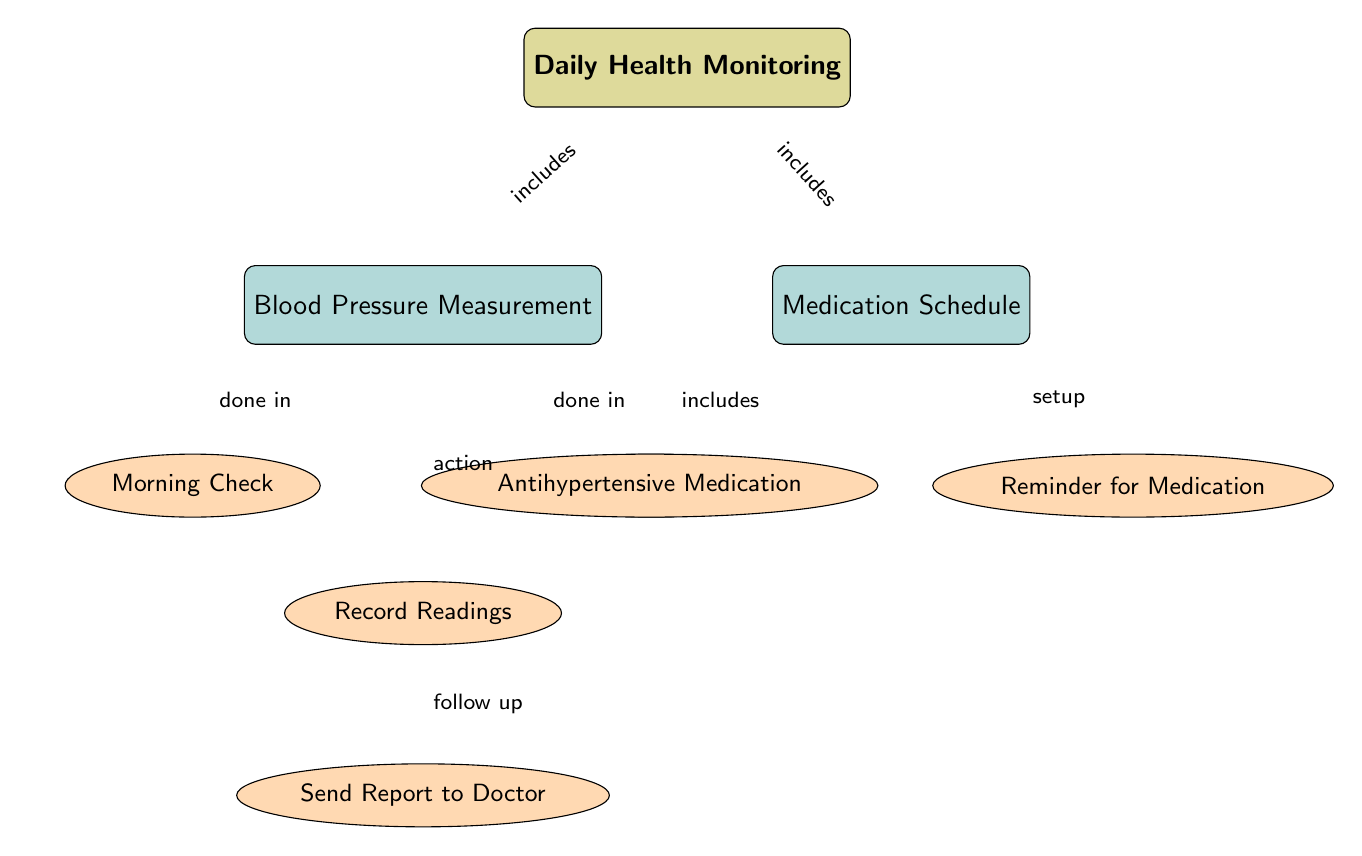What is the main focus of the diagram? The main node labeled "Daily Health Monitoring" indicates the central theme or focus of the diagram.
Answer: Daily Health Monitoring How many action nodes are present in the Blood Pressure Measurement section? The Blood Pressure Measurement section contains three action nodes: Morning Check, Evening Check, and Record Readings.
Answer: 3 Which node includes a reminder for medication? The Medication Schedule section includes a node labeled "Reminder for Medication," which indicates the reminder action for taking medication.
Answer: Reminder for Medication What two actions are performed in the Blood Pressure Measurement section? The diagram specifies two actions under Blood Pressure Measurement: Morning Check and Evening Check.
Answer: Morning Check, Evening Check What action follows after recording blood pressure readings? After the action of recording blood pressure readings, the next action indicated in the diagram is to "Send Report to Doctor."
Answer: Send Report to Doctor Which node in the diagram is responsible for Antihypertensive Medication? The node labeled "Antihypertensive Medication" is designated for medication-related actions in the Medication Schedule section, indicating what type of medication is being referred to.
Answer: Antihypertensive Medication What is the relationship between Daily Health Monitoring and Blood Pressure Measurement? The arrow between the main node "Daily Health Monitoring" and the sub-node "Blood Pressure Measurement" indicates that Blood Pressure Measurement is included in the process of Daily Health Monitoring.
Answer: includes How many total edges connect the main node to sub-nodes? The main node is connected to two sub-nodes: Blood Pressure Measurement and Medication Schedule, resulting in two edges.
Answer: 2 What does the action node "Record Readings" allow for in the process? The action node "Record Readings" allows for documentation or tracking of the blood pressure measurements obtained during the morning and evening checks.
Answer: documentation 